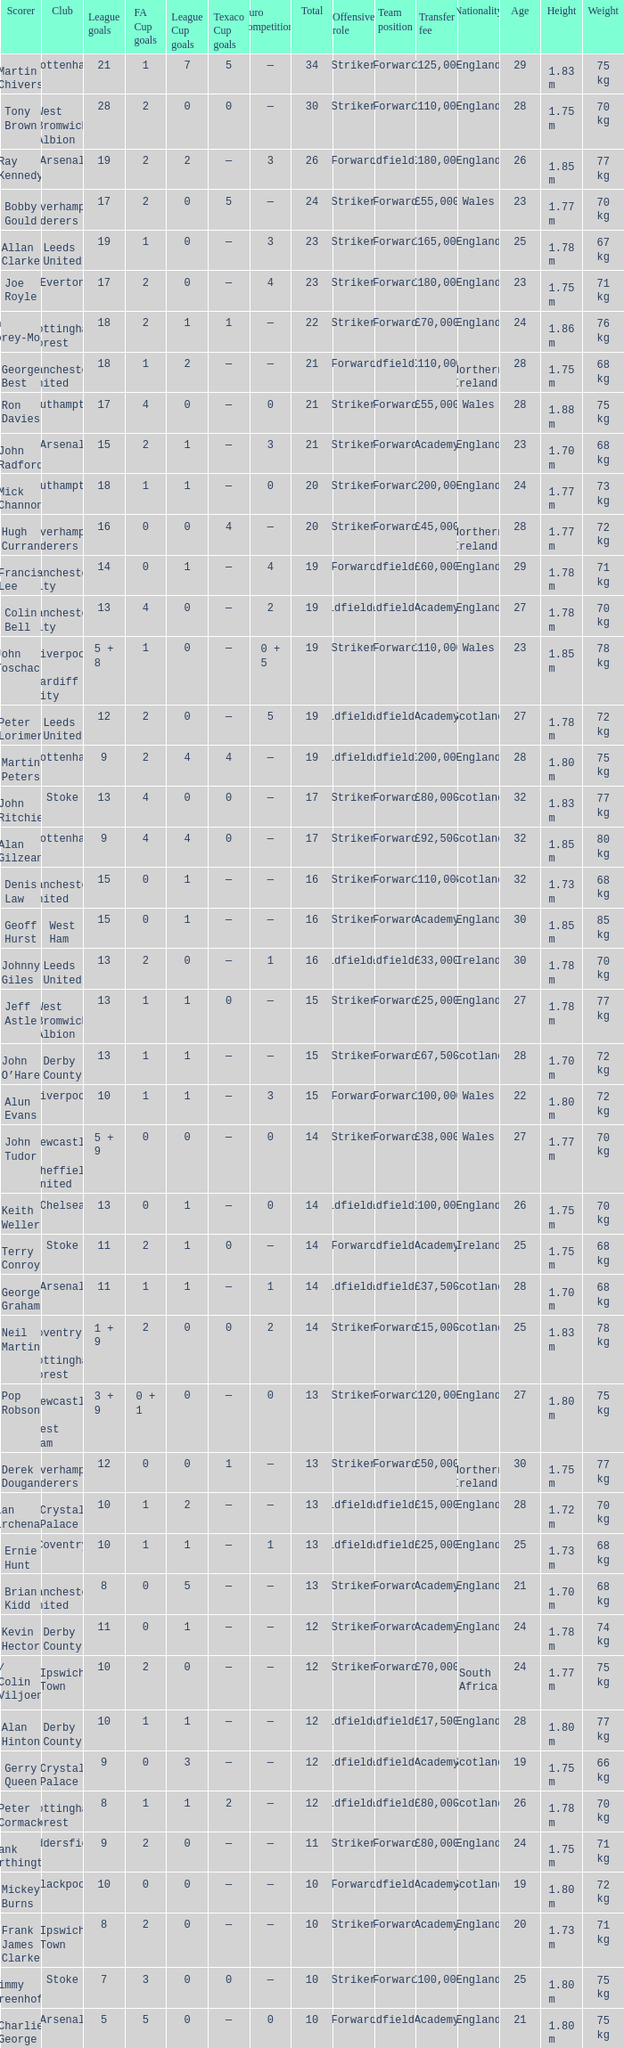What is the average Total, when FA Cup Goals is 1, when League Goals is 10, and when Club is Crystal Palace? 13.0. 